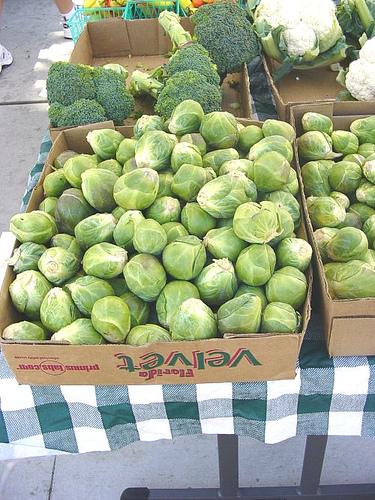Is the fruit sour?
Give a very brief answer. No. Are all the vegetables green?
Be succinct. Yes. What is the type of vegetable in the front box?
Short answer required. Brussel sprouts. How many pieces of vegetables are on the boxes?
Be succinct. 100. 